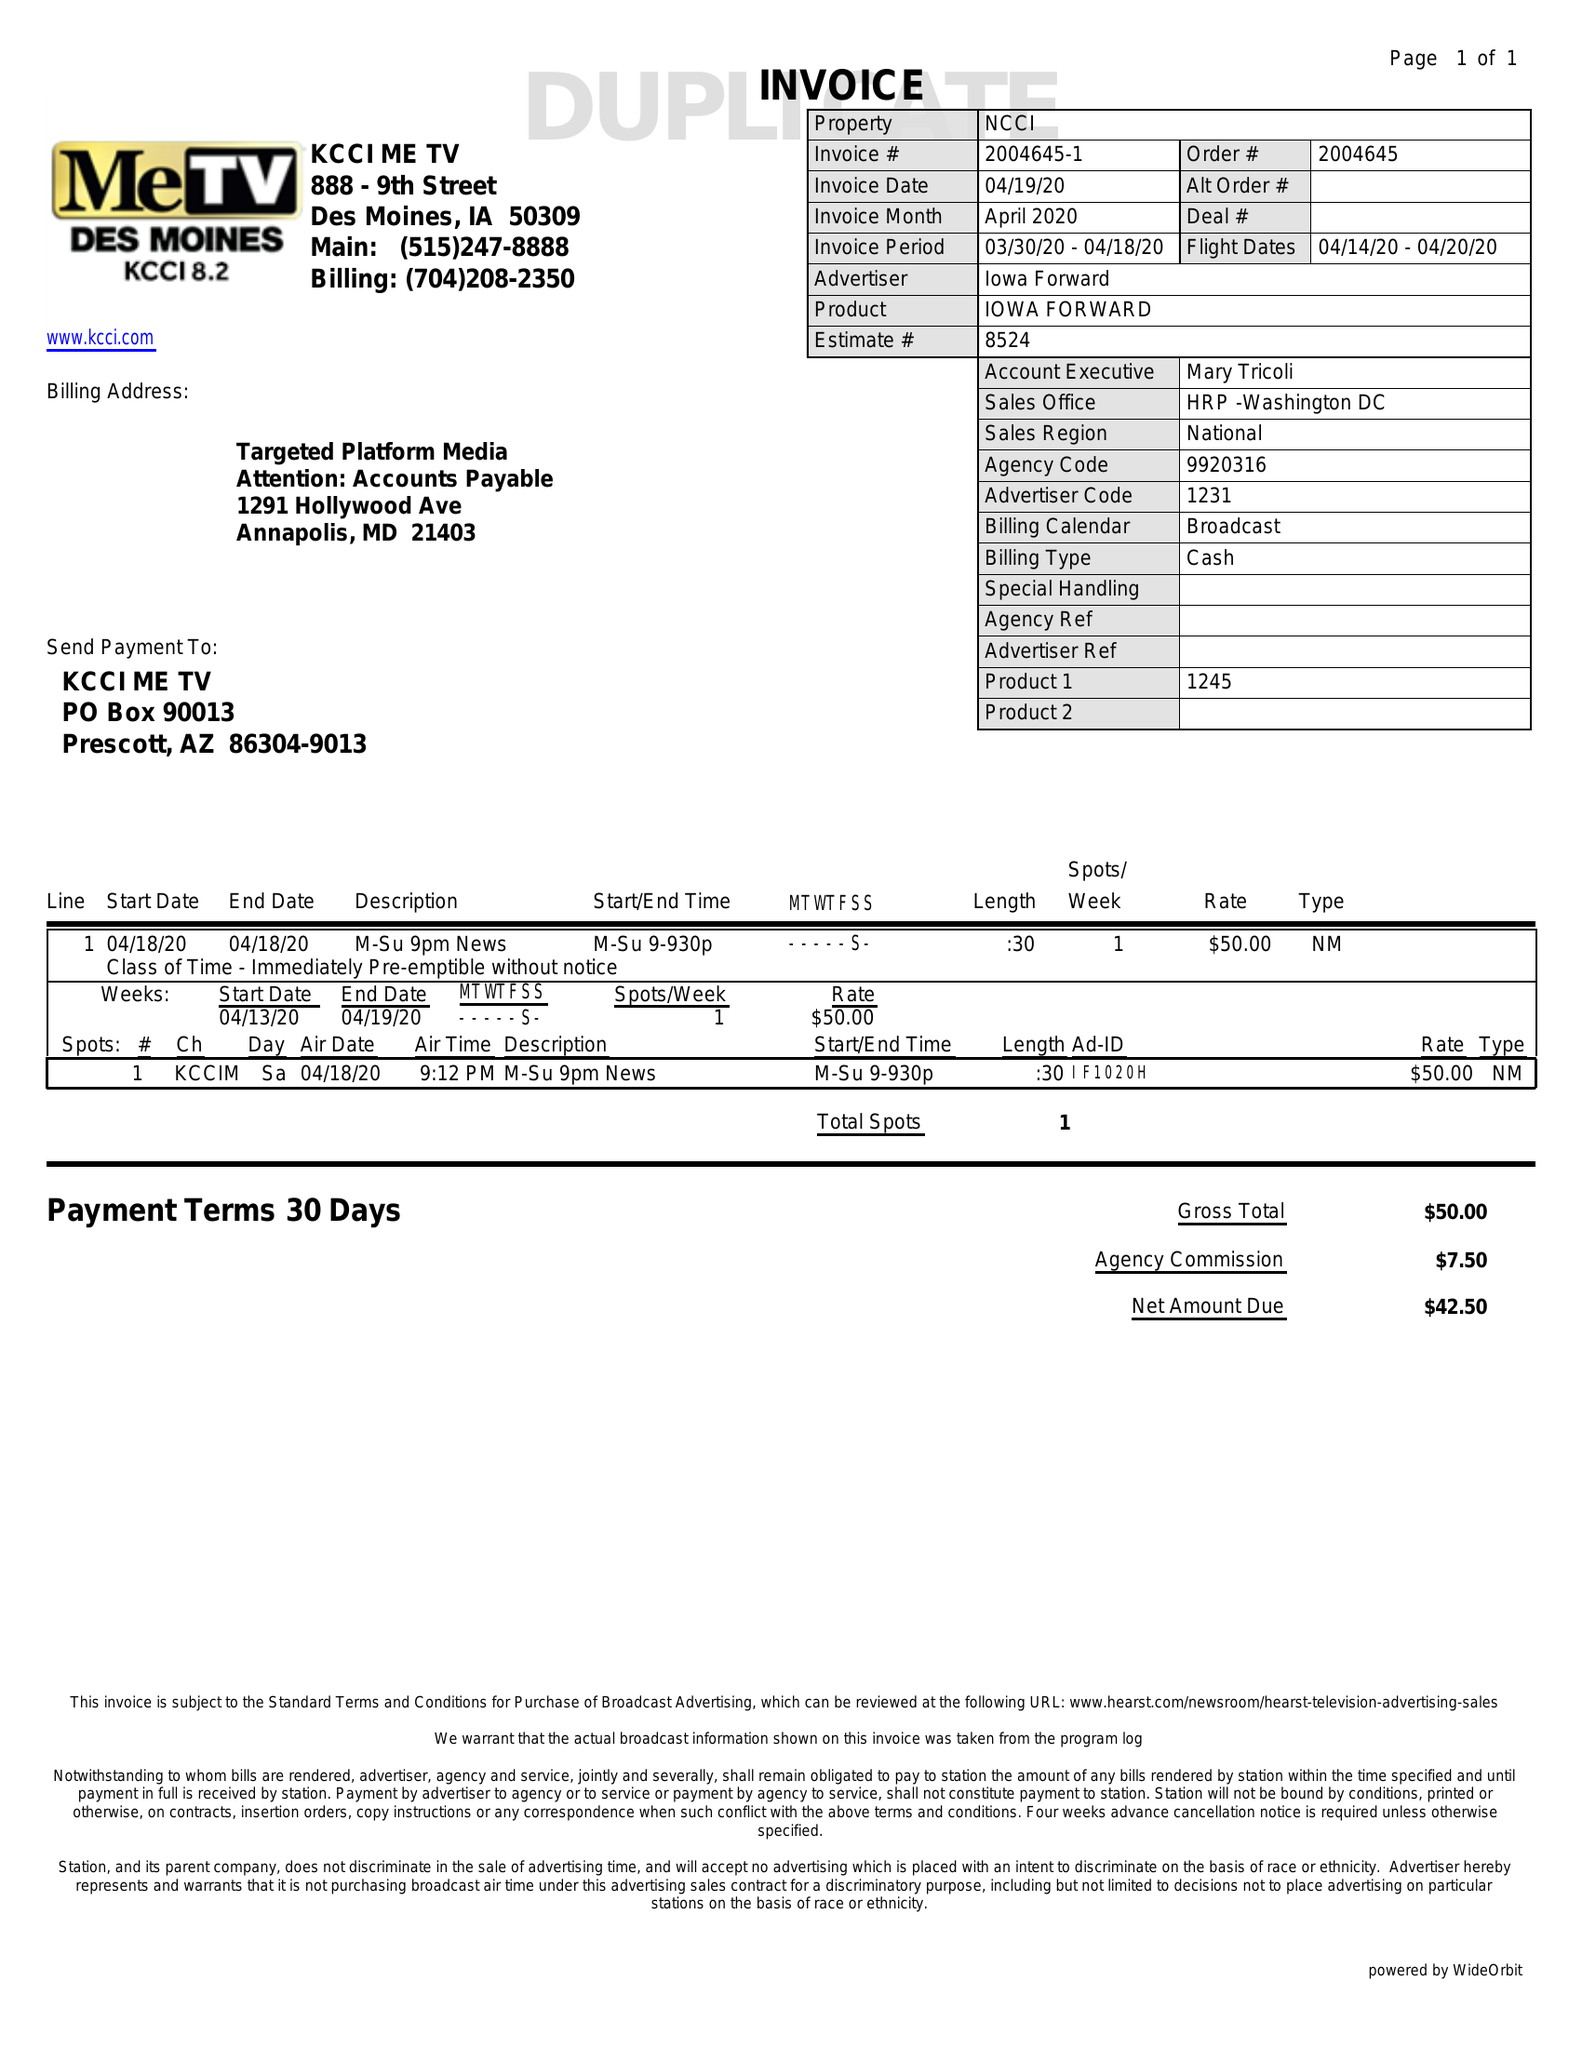What is the value for the flight_from?
Answer the question using a single word or phrase. 04/14/20 